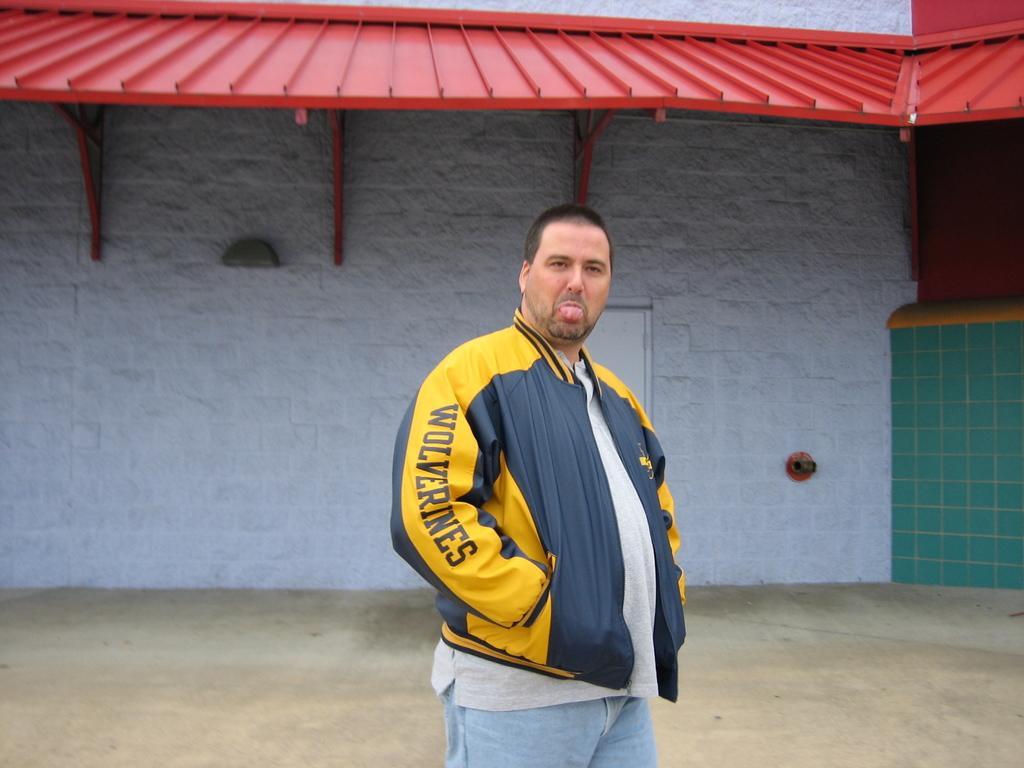Please provide a concise description of this image. In the middle a man is there, he wore yellow color coat behind him there is a wall. It is in white color. 